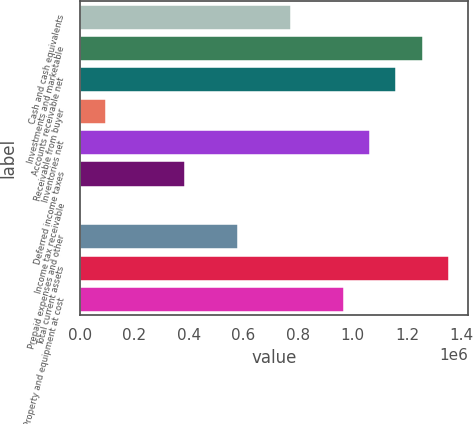<chart> <loc_0><loc_0><loc_500><loc_500><bar_chart><fcel>Cash and cash equivalents<fcel>Investments and marketable<fcel>Accounts receivable net<fcel>Receivable from buyer<fcel>Inventories net<fcel>Deferred income taxes<fcel>Income tax receivable<fcel>Prepaid expenses and other<fcel>Total current assets<fcel>Property and equipment at cost<nl><fcel>774199<fcel>1.25807e+06<fcel>1.1613e+06<fcel>96776.5<fcel>1.06452e+06<fcel>387100<fcel>1.86<fcel>580650<fcel>1.35485e+06<fcel>967748<nl></chart> 